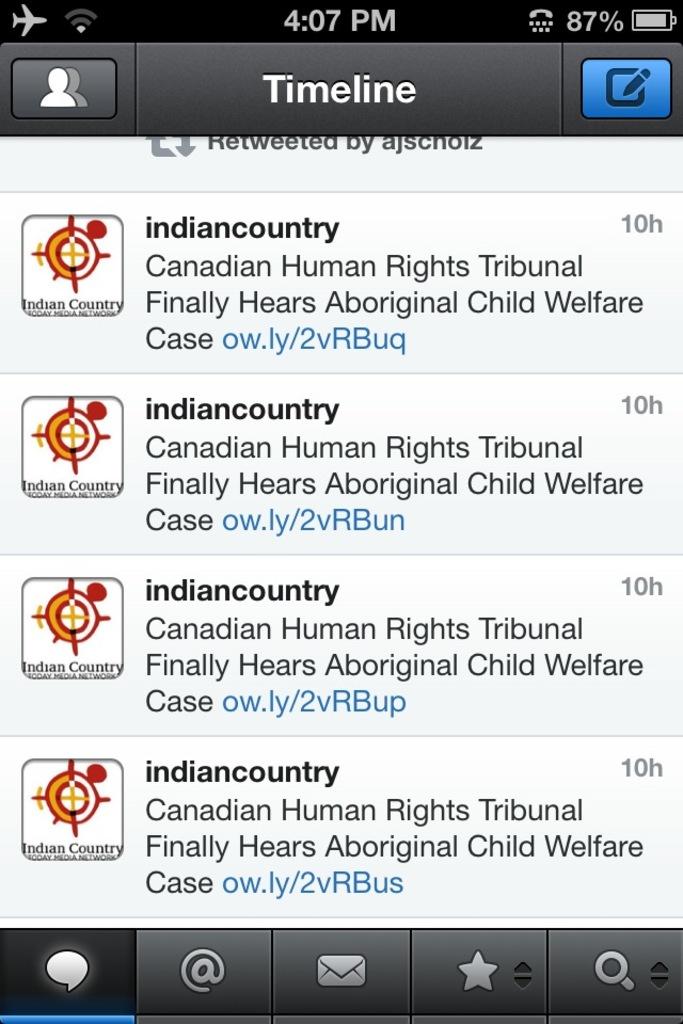The child welfare case concerns what ethnic group of people?
Give a very brief answer. Aboriginal. How long ago were these messages sent?
Provide a succinct answer. 10 hours. 